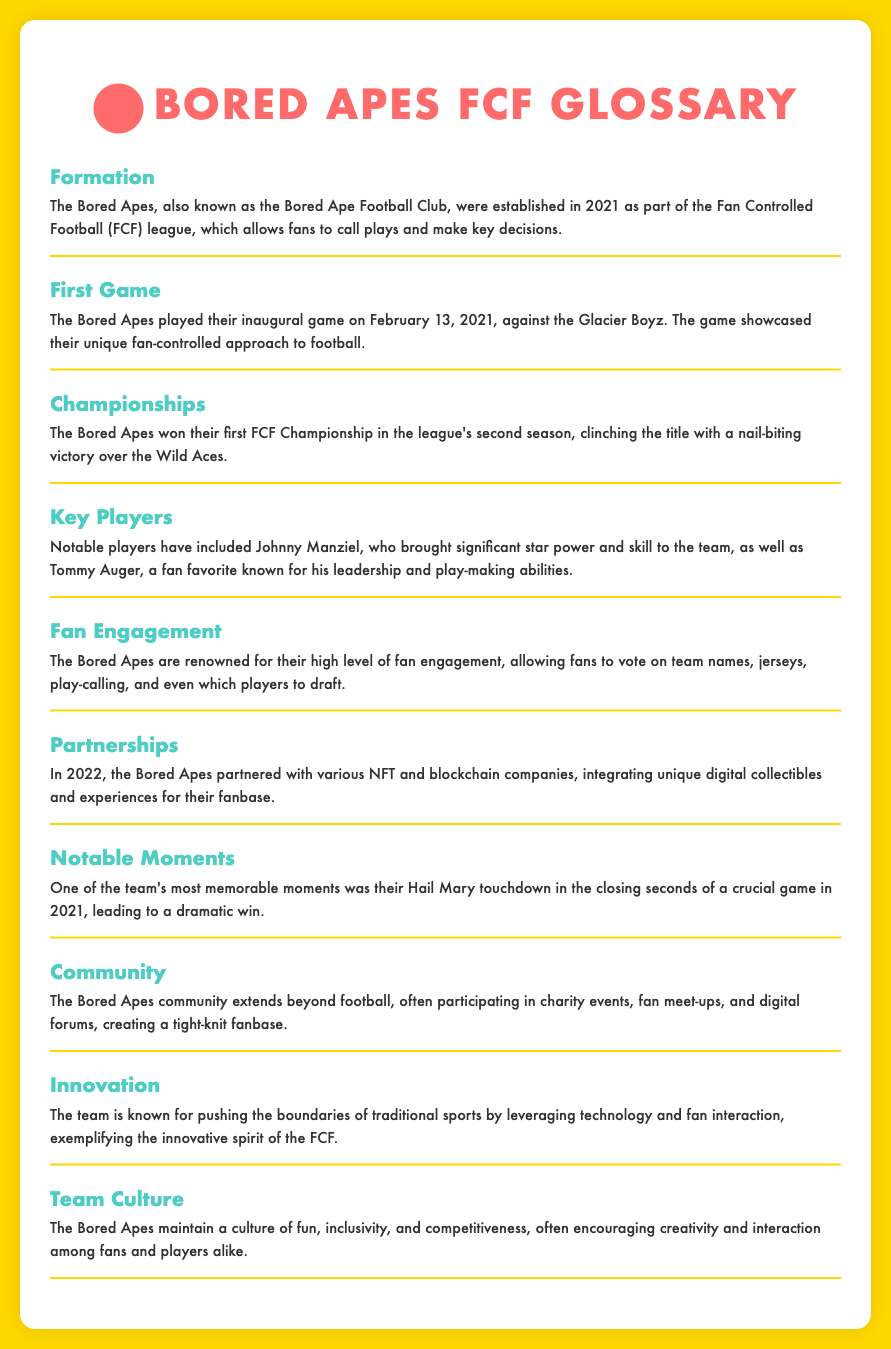What year were the Bored Apes established? The year the Bored Apes were established is mentioned in the definition of Formation in the document.
Answer: 2021 Who did the Bored Apes play in their first game? The document specifies that the Bored Apes played against the Glacier Boyz in their inaugural game.
Answer: Glacier Boyz What was a notable player for the Bored Apes? The Key Players section lists notable players, including Tommy Auger.
Answer: Tommy Auger When did the Bored Apes win their first FCF Championship? The Championships section indicates that they won their first title in the league's second season, which can be inferred to be the year following their formation in 2021.
Answer: 2022 What type of engagement is the Bored Apes known for? The document mentions that the Bored Apes are renowned for their high level of fan engagement.
Answer: Fan engagement What memorable moment happened in 2021 for the Bored Apes? According to the Notable Moments section, they had a Hail Mary touchdown in the closing seconds of a crucial game in 2021.
Answer: Hail Mary touchdown What did the Bored Apes integrate with their partnerships in 2022? The Partnerships section explains that they integrated unique digital collectibles and experiences.
Answer: Digital collectibles What culture does the Bored Apes team promote? The Team Culture section indicates that they maintain a culture of fun, inclusivity, and competitiveness.
Answer: Fun, inclusivity, and competitiveness What league do the Bored Apes belong to? The document states that the Bored Apes are part of the Fan Controlled Football league.
Answer: Fan Controlled Football 